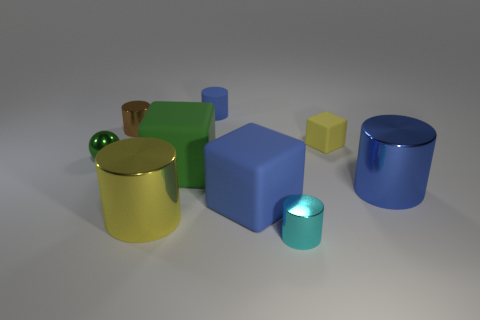Subtract all brown cylinders. How many cylinders are left? 4 Subtract all blue rubber cylinders. How many cylinders are left? 4 Subtract 1 blocks. How many blocks are left? 2 Subtract all green cylinders. Subtract all purple spheres. How many cylinders are left? 5 Subtract all cylinders. How many objects are left? 4 Subtract 1 brown cylinders. How many objects are left? 8 Subtract all purple matte cubes. Subtract all green cubes. How many objects are left? 8 Add 8 big blue cubes. How many big blue cubes are left? 9 Add 8 small blocks. How many small blocks exist? 9 